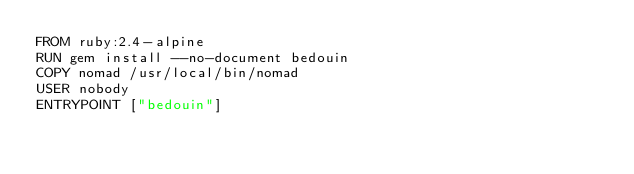Convert code to text. <code><loc_0><loc_0><loc_500><loc_500><_Dockerfile_>FROM ruby:2.4-alpine
RUN gem install --no-document bedouin
COPY nomad /usr/local/bin/nomad
USER nobody
ENTRYPOINT ["bedouin"]
</code> 